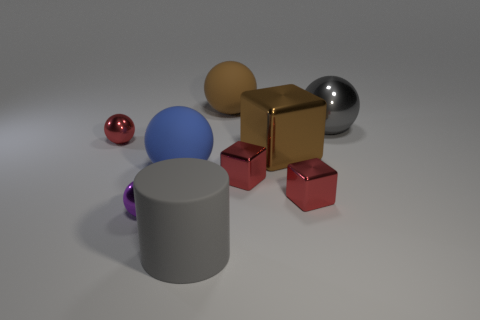Which object in the image appears to have the smoothest surface? The large metal ball seems to have the smoothest surface, reflecting light uniformly and showing clear reflections due to its polished finish. 